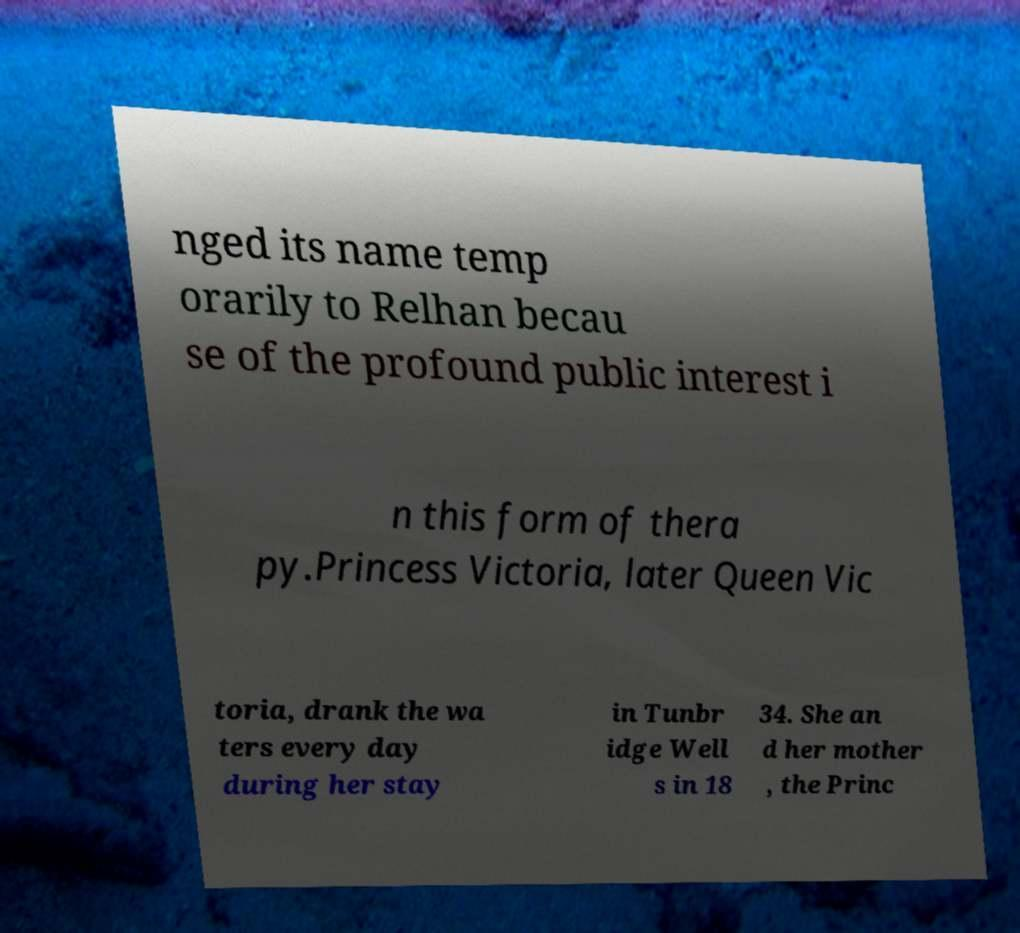For documentation purposes, I need the text within this image transcribed. Could you provide that? nged its name temp orarily to Relhan becau se of the profound public interest i n this form of thera py.Princess Victoria, later Queen Vic toria, drank the wa ters every day during her stay in Tunbr idge Well s in 18 34. She an d her mother , the Princ 